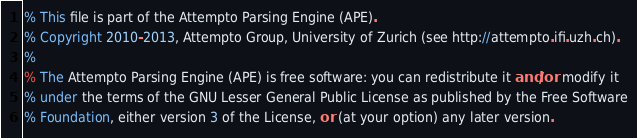<code> <loc_0><loc_0><loc_500><loc_500><_Perl_>% This file is part of the Attempto Parsing Engine (APE).
% Copyright 2010-2013, Attempto Group, University of Zurich (see http://attempto.ifi.uzh.ch).
%
% The Attempto Parsing Engine (APE) is free software: you can redistribute it and/or modify it
% under the terms of the GNU Lesser General Public License as published by the Free Software
% Foundation, either version 3 of the License, or (at your option) any later version.</code> 